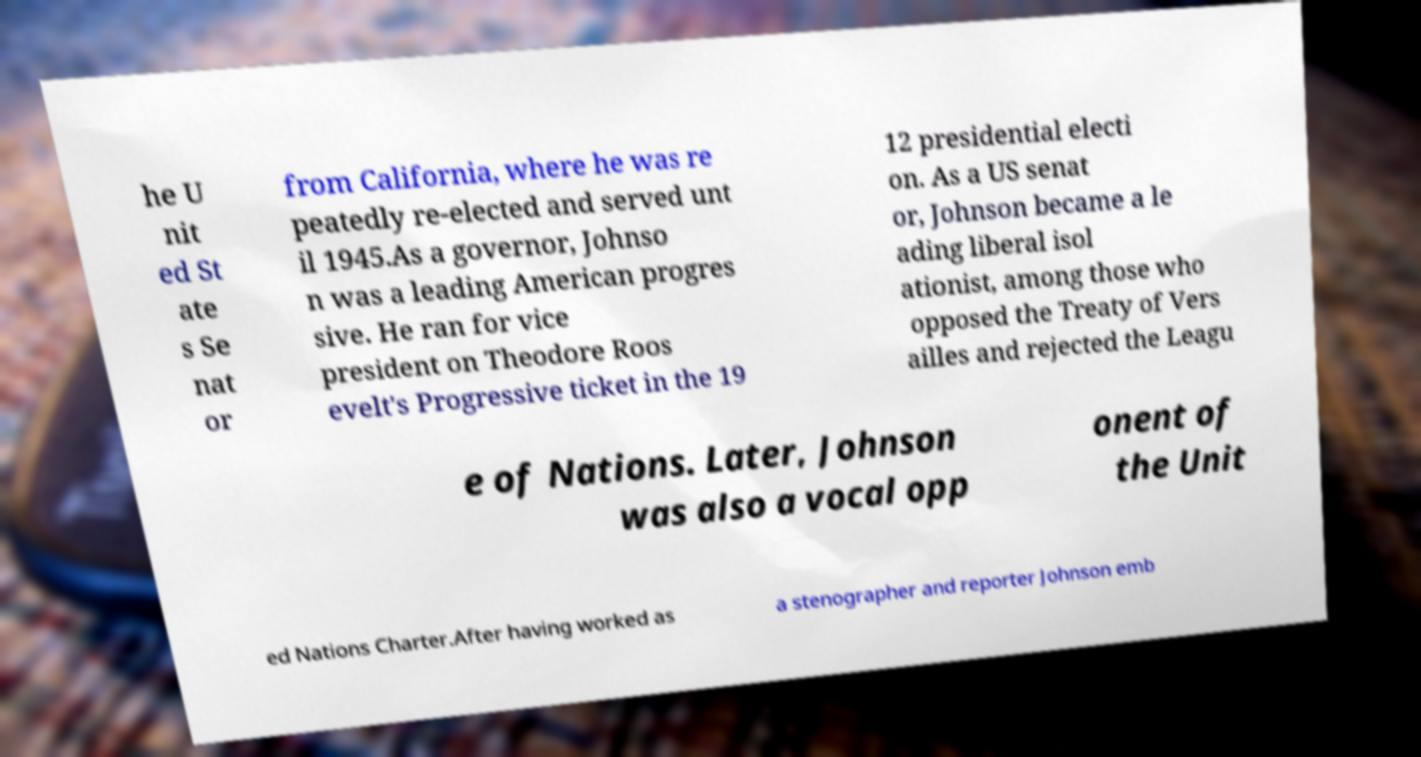What messages or text are displayed in this image? I need them in a readable, typed format. he U nit ed St ate s Se nat or from California, where he was re peatedly re-elected and served unt il 1945.As a governor, Johnso n was a leading American progres sive. He ran for vice president on Theodore Roos evelt's Progressive ticket in the 19 12 presidential electi on. As a US senat or, Johnson became a le ading liberal isol ationist, among those who opposed the Treaty of Vers ailles and rejected the Leagu e of Nations. Later, Johnson was also a vocal opp onent of the Unit ed Nations Charter.After having worked as a stenographer and reporter Johnson emb 